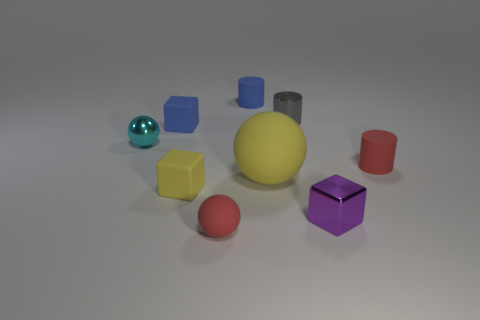Add 1 cylinders. How many objects exist? 10 Subtract all gray cylinders. How many cylinders are left? 2 Subtract 1 cylinders. How many cylinders are left? 2 Subtract all cubes. How many objects are left? 6 Subtract all small rubber blocks. Subtract all tiny metallic blocks. How many objects are left? 6 Add 1 small yellow matte blocks. How many small yellow matte blocks are left? 2 Add 5 tiny yellow things. How many tiny yellow things exist? 6 Subtract 0 brown cylinders. How many objects are left? 9 Subtract all cyan spheres. Subtract all green cylinders. How many spheres are left? 2 Subtract all yellow cylinders. How many yellow blocks are left? 1 